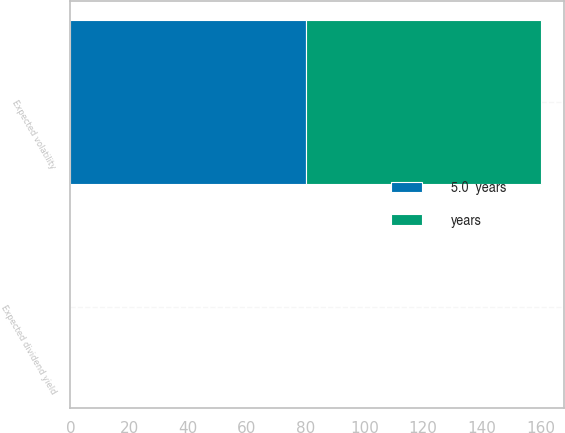<chart> <loc_0><loc_0><loc_500><loc_500><stacked_bar_chart><ecel><fcel>Expected volatility<fcel>Expected dividend yield<nl><fcel>years<fcel>80<fcel>0<nl><fcel>5.0  years<fcel>80<fcel>0<nl></chart> 